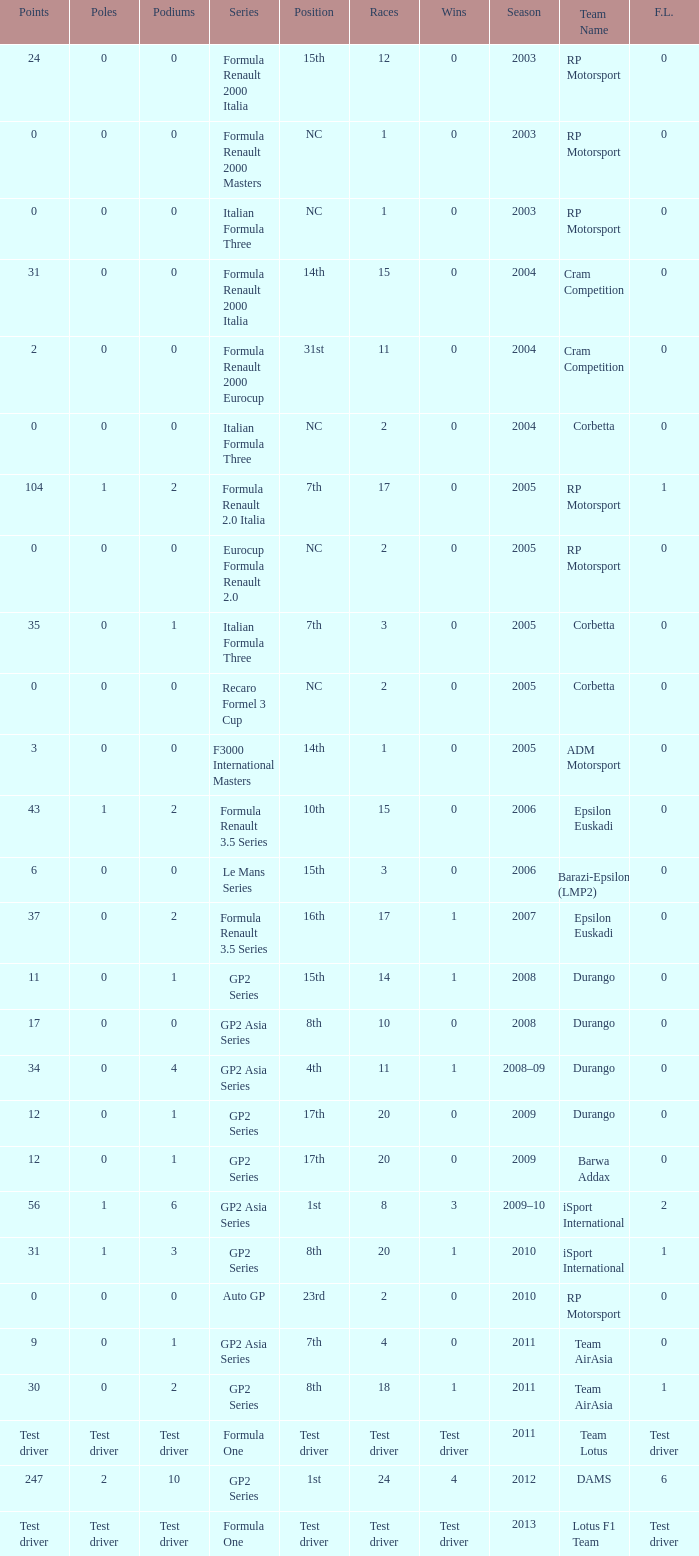What is the number of podiums with 0 wins and 6 points? 0.0. I'm looking to parse the entire table for insights. Could you assist me with that? {'header': ['Points', 'Poles', 'Podiums', 'Series', 'Position', 'Races', 'Wins', 'Season', 'Team Name', 'F.L.'], 'rows': [['24', '0', '0', 'Formula Renault 2000 Italia', '15th', '12', '0', '2003', 'RP Motorsport', '0'], ['0', '0', '0', 'Formula Renault 2000 Masters', 'NC', '1', '0', '2003', 'RP Motorsport', '0'], ['0', '0', '0', 'Italian Formula Three', 'NC', '1', '0', '2003', 'RP Motorsport', '0'], ['31', '0', '0', 'Formula Renault 2000 Italia', '14th', '15', '0', '2004', 'Cram Competition', '0'], ['2', '0', '0', 'Formula Renault 2000 Eurocup', '31st', '11', '0', '2004', 'Cram Competition', '0'], ['0', '0', '0', 'Italian Formula Three', 'NC', '2', '0', '2004', 'Corbetta', '0'], ['104', '1', '2', 'Formula Renault 2.0 Italia', '7th', '17', '0', '2005', 'RP Motorsport', '1'], ['0', '0', '0', 'Eurocup Formula Renault 2.0', 'NC', '2', '0', '2005', 'RP Motorsport', '0'], ['35', '0', '1', 'Italian Formula Three', '7th', '3', '0', '2005', 'Corbetta', '0'], ['0', '0', '0', 'Recaro Formel 3 Cup', 'NC', '2', '0', '2005', 'Corbetta', '0'], ['3', '0', '0', 'F3000 International Masters', '14th', '1', '0', '2005', 'ADM Motorsport', '0'], ['43', '1', '2', 'Formula Renault 3.5 Series', '10th', '15', '0', '2006', 'Epsilon Euskadi', '0'], ['6', '0', '0', 'Le Mans Series', '15th', '3', '0', '2006', 'Barazi-Epsilon (LMP2)', '0'], ['37', '0', '2', 'Formula Renault 3.5 Series', '16th', '17', '1', '2007', 'Epsilon Euskadi', '0'], ['11', '0', '1', 'GP2 Series', '15th', '14', '1', '2008', 'Durango', '0'], ['17', '0', '0', 'GP2 Asia Series', '8th', '10', '0', '2008', 'Durango', '0'], ['34', '0', '4', 'GP2 Asia Series', '4th', '11', '1', '2008–09', 'Durango', '0'], ['12', '0', '1', 'GP2 Series', '17th', '20', '0', '2009', 'Durango', '0'], ['12', '0', '1', 'GP2 Series', '17th', '20', '0', '2009', 'Barwa Addax', '0'], ['56', '1', '6', 'GP2 Asia Series', '1st', '8', '3', '2009–10', 'iSport International', '2'], ['31', '1', '3', 'GP2 Series', '8th', '20', '1', '2010', 'iSport International', '1'], ['0', '0', '0', 'Auto GP', '23rd', '2', '0', '2010', 'RP Motorsport', '0'], ['9', '0', '1', 'GP2 Asia Series', '7th', '4', '0', '2011', 'Team AirAsia', '0'], ['30', '0', '2', 'GP2 Series', '8th', '18', '1', '2011', 'Team AirAsia', '1'], ['Test driver', 'Test driver', 'Test driver', 'Formula One', 'Test driver', 'Test driver', 'Test driver', '2011', 'Team Lotus', 'Test driver'], ['247', '2', '10', 'GP2 Series', '1st', '24', '4', '2012', 'DAMS', '6'], ['Test driver', 'Test driver', 'Test driver', 'Formula One', 'Test driver', 'Test driver', 'Test driver', '2013', 'Lotus F1 Team', 'Test driver']]} 